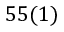<formula> <loc_0><loc_0><loc_500><loc_500>5 5 ( 1 )</formula> 